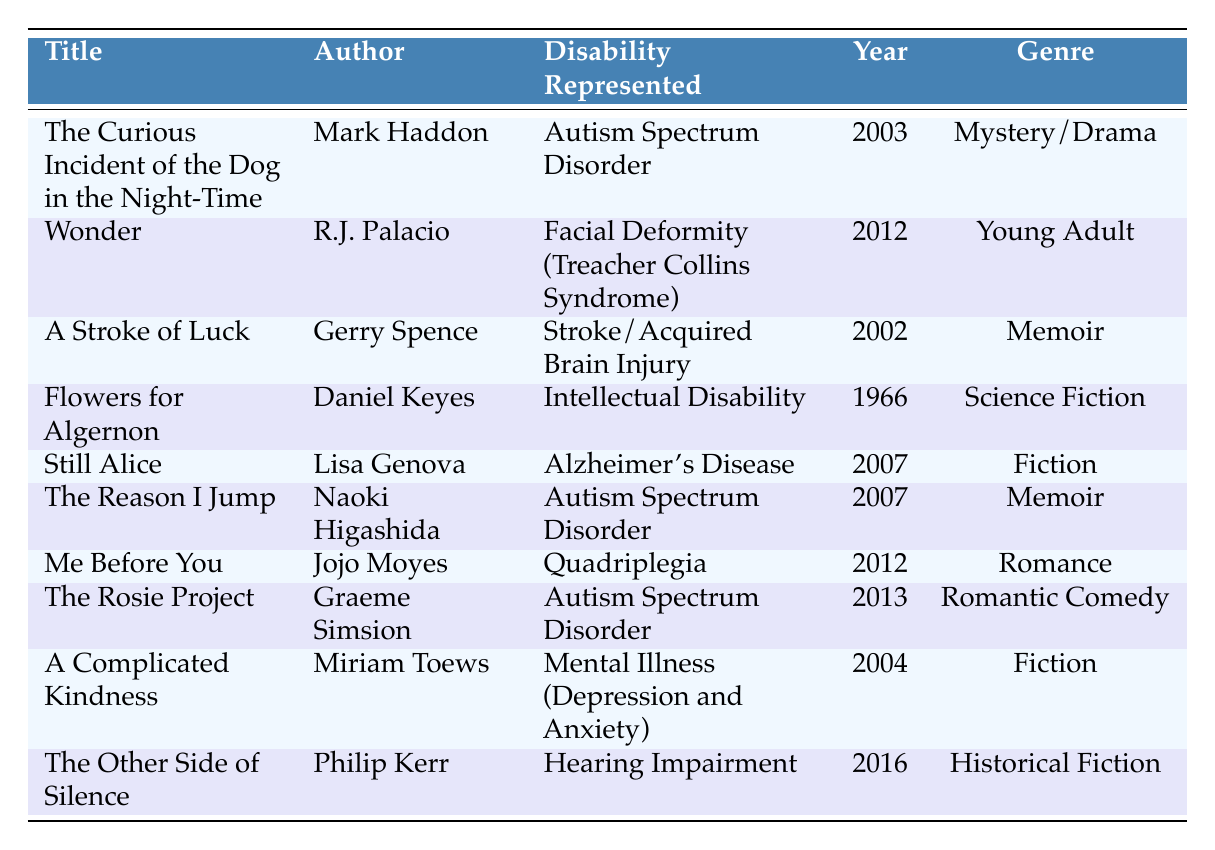What is the title of the book that represents Autism Spectrum Disorder published in 2003? The table lists "The Curious Incident of the Dog in the Night-Time" by Mark Haddon under the disability of Autism Spectrum Disorder published in 2003.
Answer: The Curious Incident of the Dog in the Night-Time How many books are listed under the genre of Memoir? There are two memoirs in the table: "A Stroke of Luck" by Gerry Spence and "The Reason I Jump" by Naoki Higashida.
Answer: 2 What is the genre of "Me Before You"? The table specifies that "Me Before You" by Jojo Moyes falls under the Romance genre.
Answer: Romance Is "Wonder" the only book representing Facial Deformity? Checking the table, "Wonder" by R.J. Palacio is the only entry specifically mentioning Facial Deformity. No other entries connect to this disability.
Answer: Yes How many years separate the publication of "Flowers for Algernon" and "The Rosie Project"? "Flowers for Algernon" was published in 1966 and "The Rosie Project" in 2013. The difference is 2013 - 1966 = 47 years.
Answer: 47 years Which author has written multiple books representing Autism Spectrum Disorder? The table shows Mark Haddon, Naoki Higashida, and Graeme Simsion as authors, but three separate works representing Autism are linked to the latter three authors, meaning multiple authors are involved.
Answer: Mark Haddon, Naoki Higashida, Graeme Simsion What is the average year of publication for the books listed in the table? The years of publication are 2003, 2012, 2002, 1966, 2007, 2007, 2012, 2013, 2004, and 2016. Adding them gives 2003 + 2012 + 2002 + 1966 + 2007 + 2007 + 2012 + 2013 + 2004 + 2016 = 2000, then dividing by 10 results in an average of 2000.
Answer: 2000 Which disability is represented in the most recent publication listed? The last entry in the table is "The Other Side of Silence" published in 2016, which represents Hearing Impairment.
Answer: Hearing Impairment What percentage of the books listed represent Autism Spectrum Disorder? There are three books representing Autism out of ten total books, resulting in a percentage of (3/10) * 100 = 30%.
Answer: 30% 